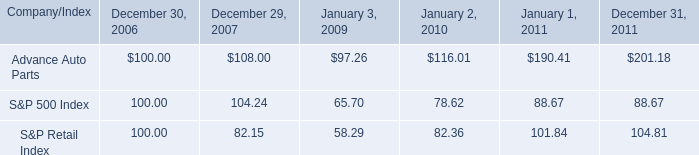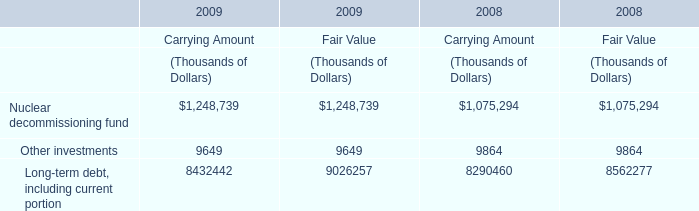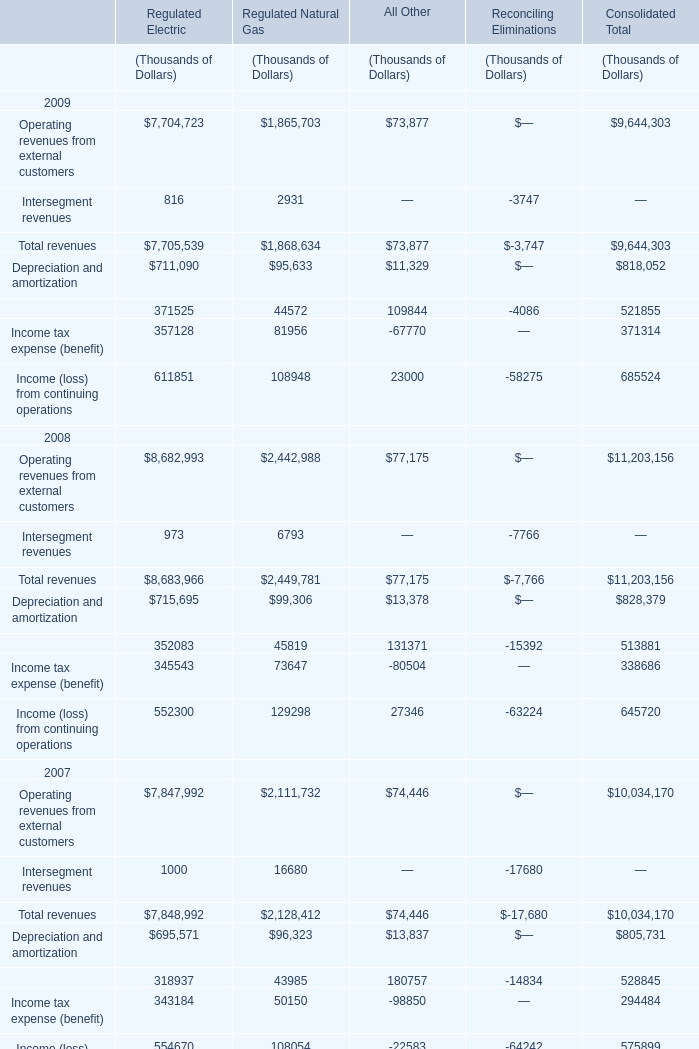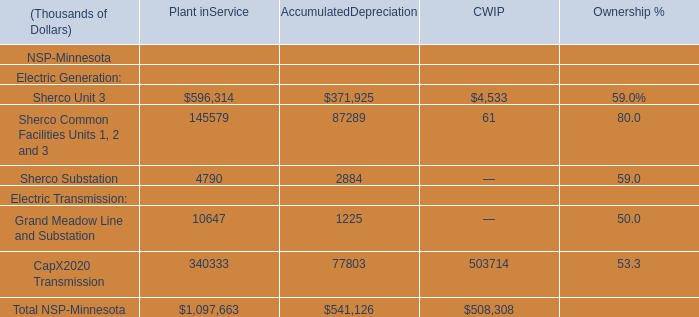What is the sum of Other investments of Carrying Amount in 2008 and Sherco Substation for Plant inService? (in thousand) 
Computations: (9864 + 4790)
Answer: 14654.0. 